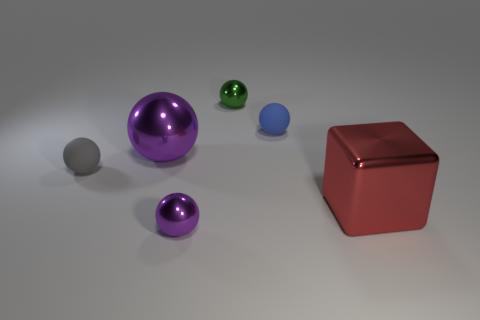Does the purple metal ball behind the red thing have the same size as the shiny thing to the right of the small blue sphere? The purple metal ball appears to be larger than the shiny object to the right of the small blue sphere when comparing their visible sizes. However, without knowing the exact distances from the viewpoint, it is challenging to ascertain accurate relative sizes solely from this image. 